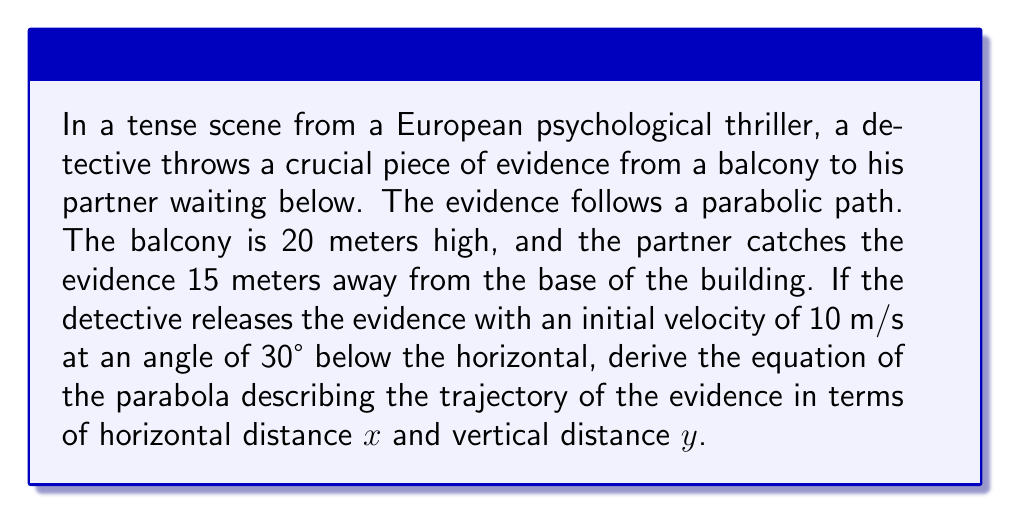What is the answer to this math problem? To solve this problem, we'll use the equations of motion for projectile motion and derive the parabolic equation. Let's break it down step-by-step:

1) First, let's define our coordinate system. We'll set the origin (0,0) at the point where the detective releases the evidence.

2) The initial velocity components are:
   $v_{0x} = 10 \cos(30°) = 10 \cdot \frac{\sqrt{3}}{2} \approx 8.66$ m/s
   $v_{0y} = -10 \sin(30°) = -10 \cdot \frac{1}{2} = -5$ m/s (negative because it's directed downward)

3) The equations of motion for x and y are:
   $x = v_{0x}t$
   $y = -20 + v_{0y}t - \frac{1}{2}gt^2$, where g = 9.8 m/s²

4) We can express t in terms of x:
   $t = \frac{x}{v_{0x}} = \frac{x}{10 \cos(30°)} = \frac{2x}{10\sqrt{3}}$

5) Substituting this into the y equation:
   $y = -20 + v_{0y}\cdot\frac{2x}{10\sqrt{3}} - \frac{1}{2}g\cdot(\frac{2x}{10\sqrt{3}})^2$

6) Simplifying:
   $y = -20 - \frac{x}{\sqrt{3}} - \frac{9.8}{2}\cdot\frac{4x^2}{300}$
   $y = -20 - \frac{x}{\sqrt{3}} - \frac{0.0653x^2}{2}$

7) This is our parabolic equation in the form $y = ax^2 + bx + c$, where:
   $a = -\frac{0.0653}{2}$
   $b = -\frac{1}{\sqrt{3}}$
   $c = -20$

Therefore, the equation of the parabola is:

$$y = -0.03265x^2 - \frac{x}{\sqrt{3}} - 20$$
Answer: $y = -0.03265x^2 - \frac{x}{\sqrt{3}} - 20$ 